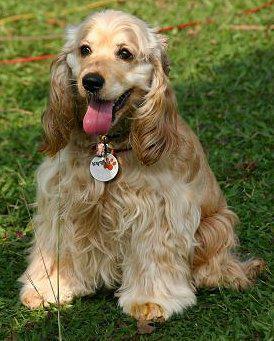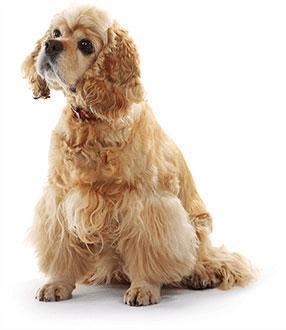The first image is the image on the left, the second image is the image on the right. Given the left and right images, does the statement "An image contains a dog food bowl." hold true? Answer yes or no. No. The first image is the image on the left, the second image is the image on the right. Given the left and right images, does the statement "An image includes one golden cocker spaniel with its mouth on an orangish food bowl." hold true? Answer yes or no. No. 